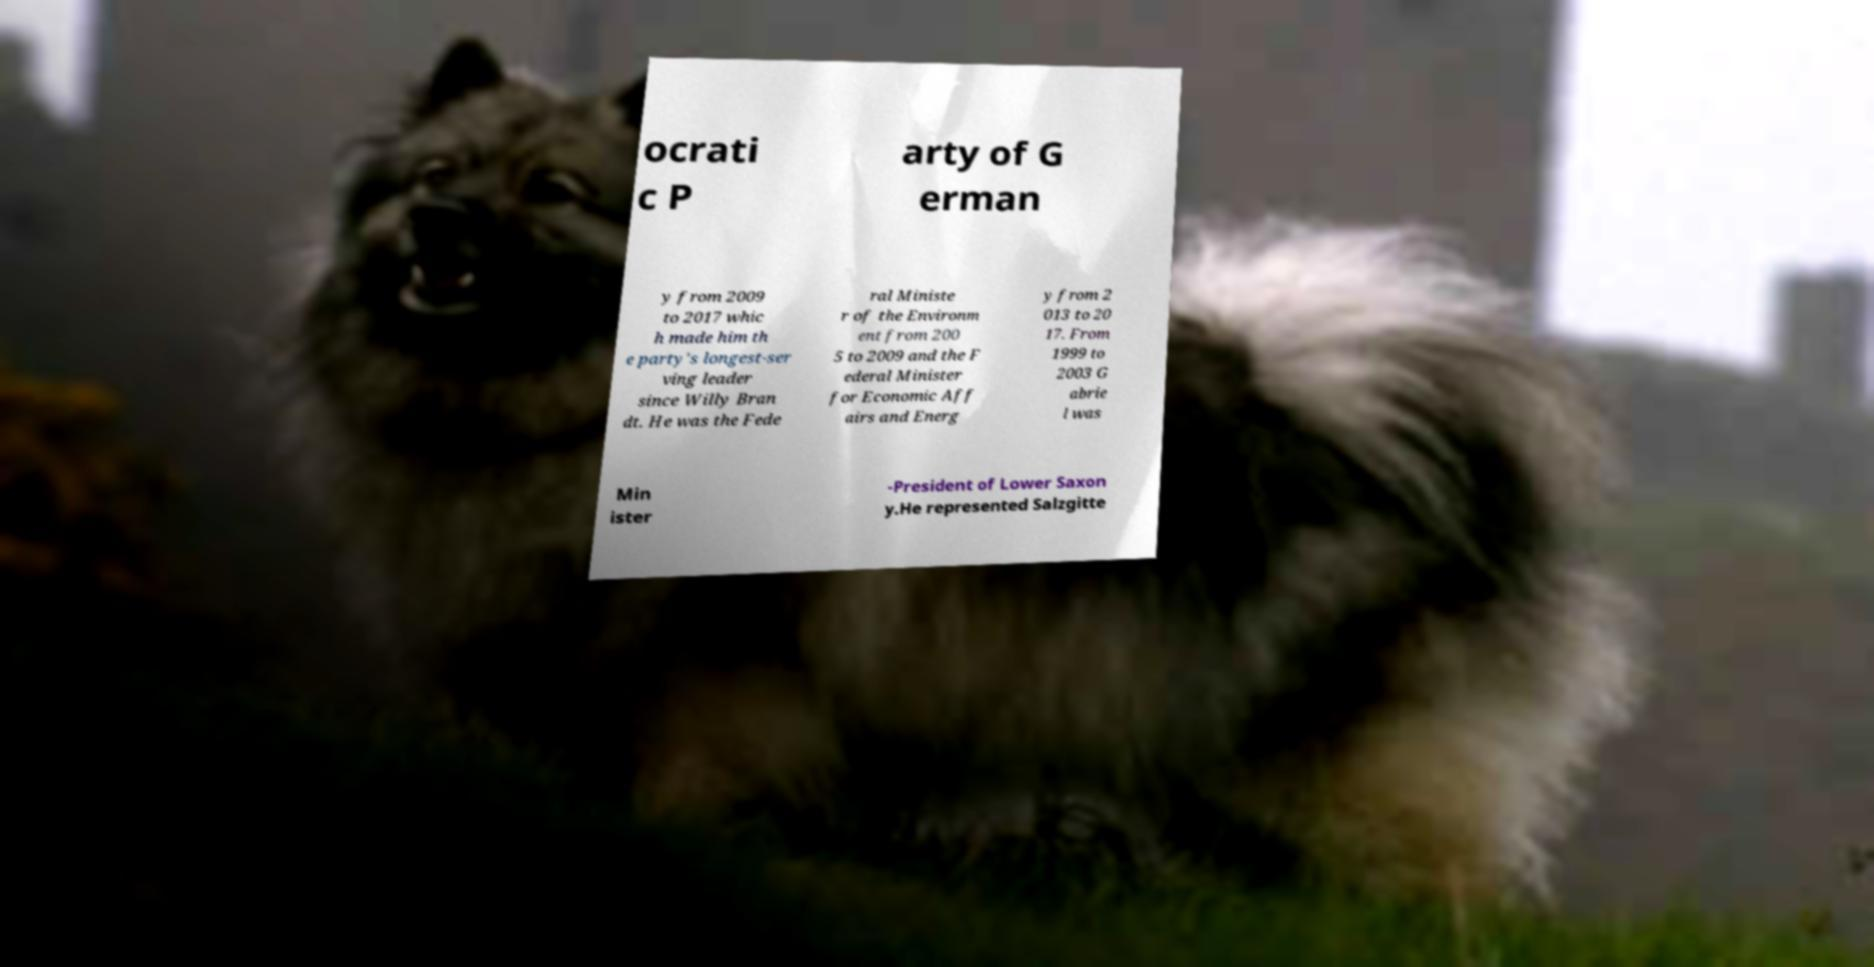Could you extract and type out the text from this image? ocrati c P arty of G erman y from 2009 to 2017 whic h made him th e party's longest-ser ving leader since Willy Bran dt. He was the Fede ral Ministe r of the Environm ent from 200 5 to 2009 and the F ederal Minister for Economic Aff airs and Energ y from 2 013 to 20 17. From 1999 to 2003 G abrie l was Min ister -President of Lower Saxon y.He represented Salzgitte 